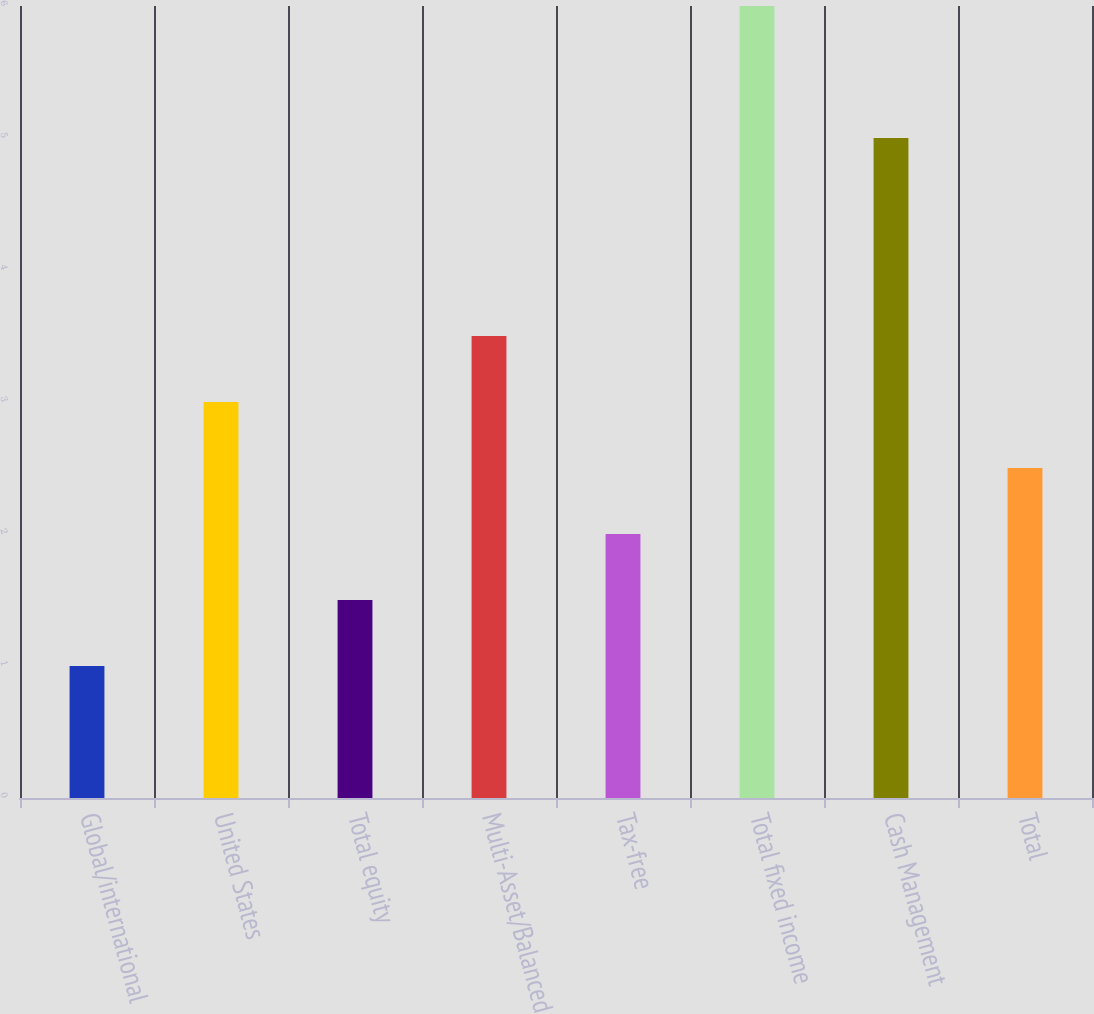Convert chart. <chart><loc_0><loc_0><loc_500><loc_500><bar_chart><fcel>Global/international<fcel>United States<fcel>Total equity<fcel>Multi-Asset/Balanced<fcel>Tax-free<fcel>Total fixed income<fcel>Cash Management<fcel>Total<nl><fcel>1<fcel>3<fcel>1.5<fcel>3.5<fcel>2<fcel>6<fcel>5<fcel>2.5<nl></chart> 